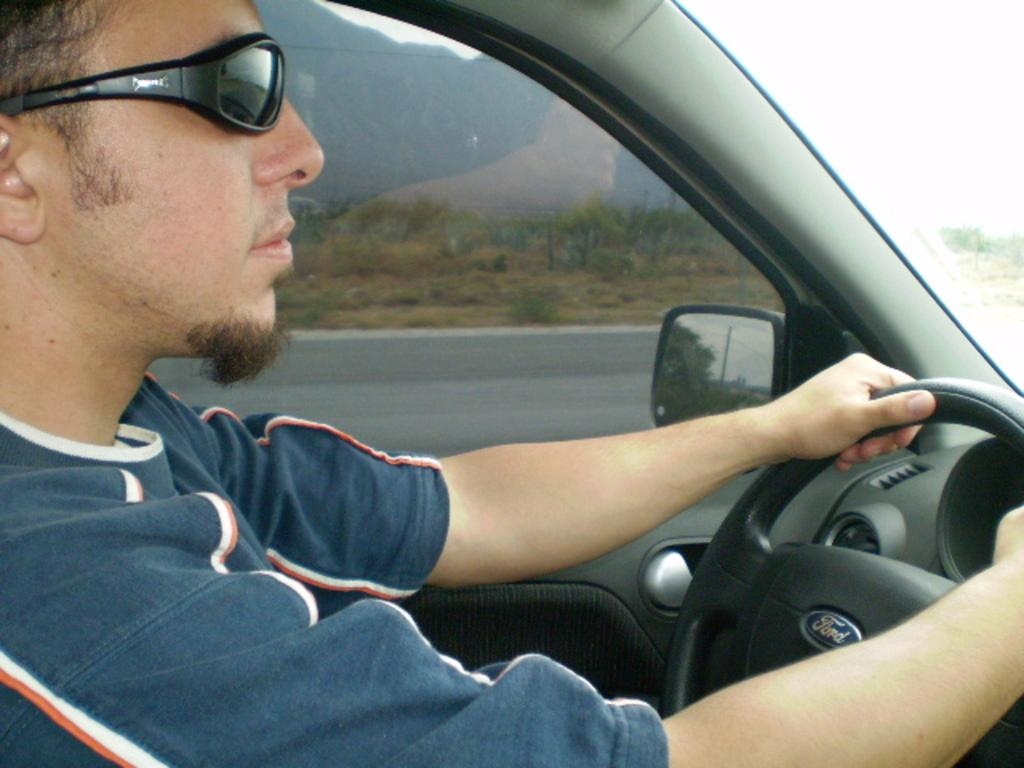What is the person in the image doing? There is a person riding a car in the image. What can be seen in the background of the image? There are trees and mountains in the background of the image. What type of jelly can be seen on the person's hands in the image? There is no jelly present on the person's hands or anywhere else in the image. 